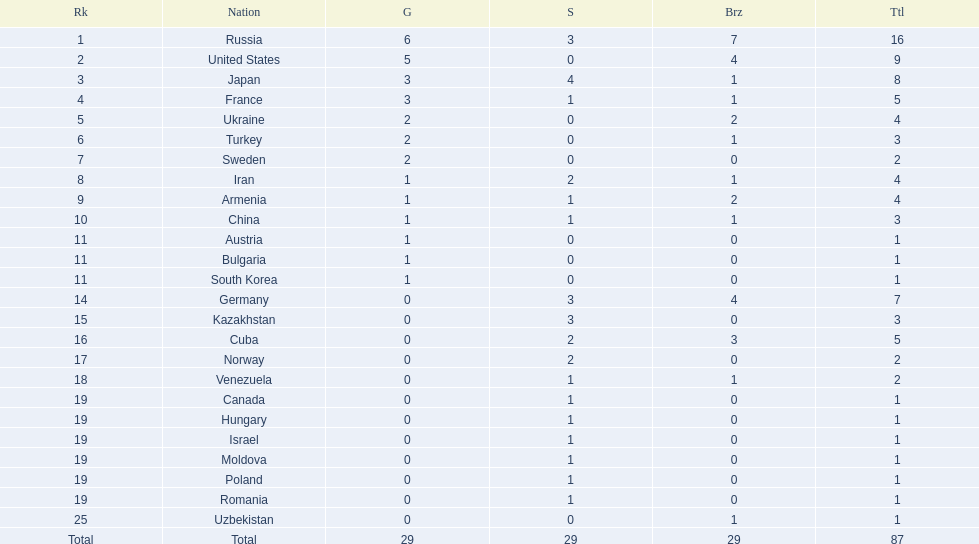What nations have one gold medal? Iran, Armenia, China, Austria, Bulgaria, South Korea. Of these, which nations have zero silver medals? Austria, Bulgaria, South Korea. Of these, which nations also have zero bronze medals? Austria. 